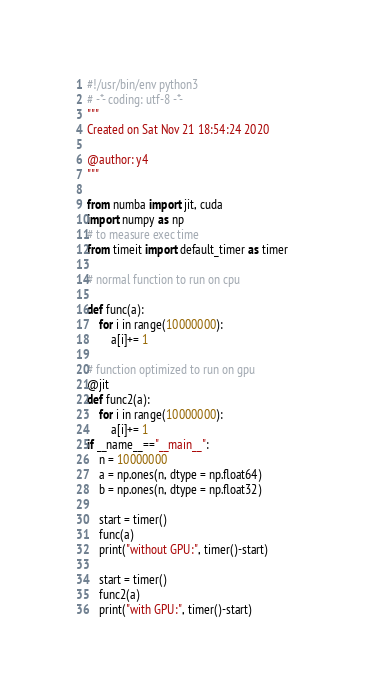<code> <loc_0><loc_0><loc_500><loc_500><_Python_>#!/usr/bin/env python3
# -*- coding: utf-8 -*-
"""
Created on Sat Nov 21 18:54:24 2020

@author: y4
"""

from numba import jit, cuda 
import numpy as np 
# to measure exec time 
from timeit import default_timer as timer    
  
# normal function to run on cpu 

def func(a):                                 
    for i in range(10000000): 
        a[i]+= 1      
  
# function optimized to run on gpu  
@jit
def func2(a): 
    for i in range(10000000): 
        a[i]+= 1
if __name__=="__main__": 
    n = 10000000                            
    a = np.ones(n, dtype = np.float64) 
    b = np.ones(n, dtype = np.float32) 
      
    start = timer() 
    func(a) 
    print("without GPU:", timer()-start)     
      
    start = timer() 
    func2(a) 
    print("with GPU:", timer()-start) </code> 